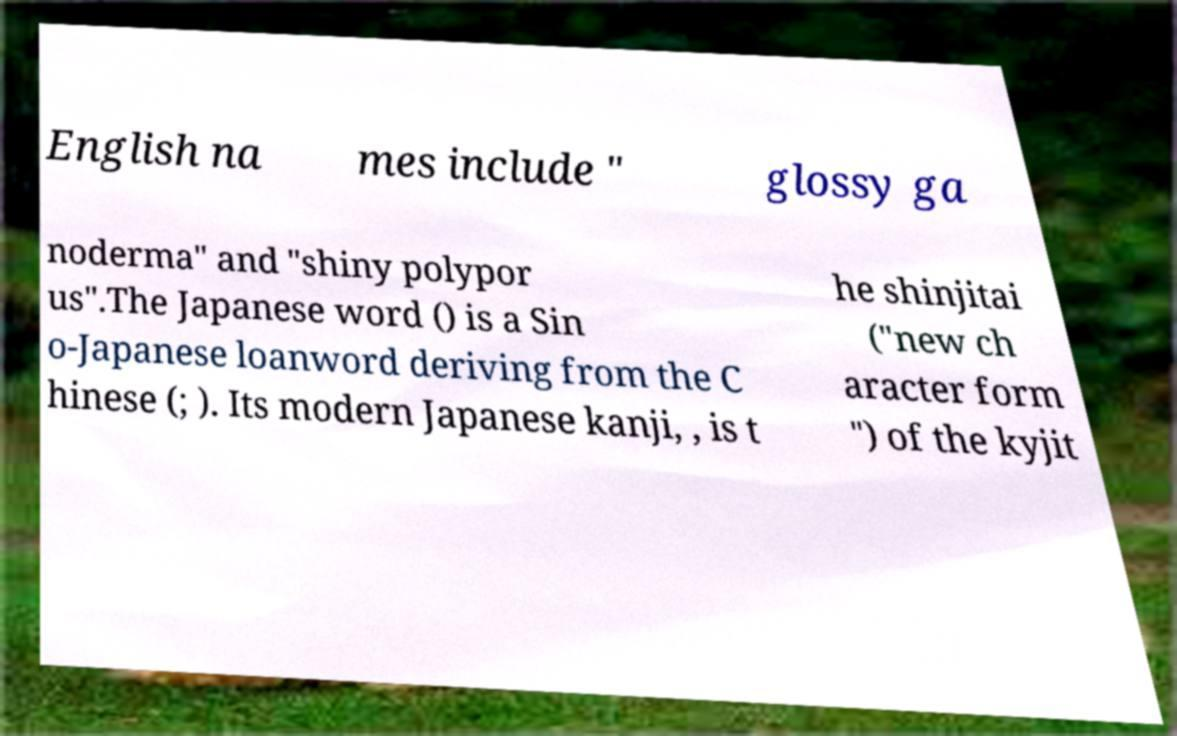Can you read and provide the text displayed in the image?This photo seems to have some interesting text. Can you extract and type it out for me? English na mes include " glossy ga noderma" and "shiny polypor us".The Japanese word () is a Sin o-Japanese loanword deriving from the C hinese (; ). Its modern Japanese kanji, , is t he shinjitai ("new ch aracter form ") of the kyjit 